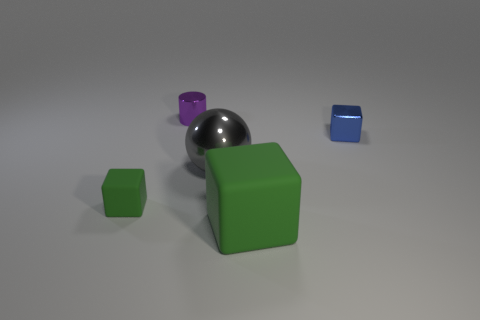What kind of surface do the objects appear to be on? The objects in the image appear to be placed on a flat, matte surface that likely represents a neutral ground, often used as a backdrop for displaying and contrasting the items. This kind of surface is common in product visuals or computer renderings to highlight the objects without any distracting elements. 